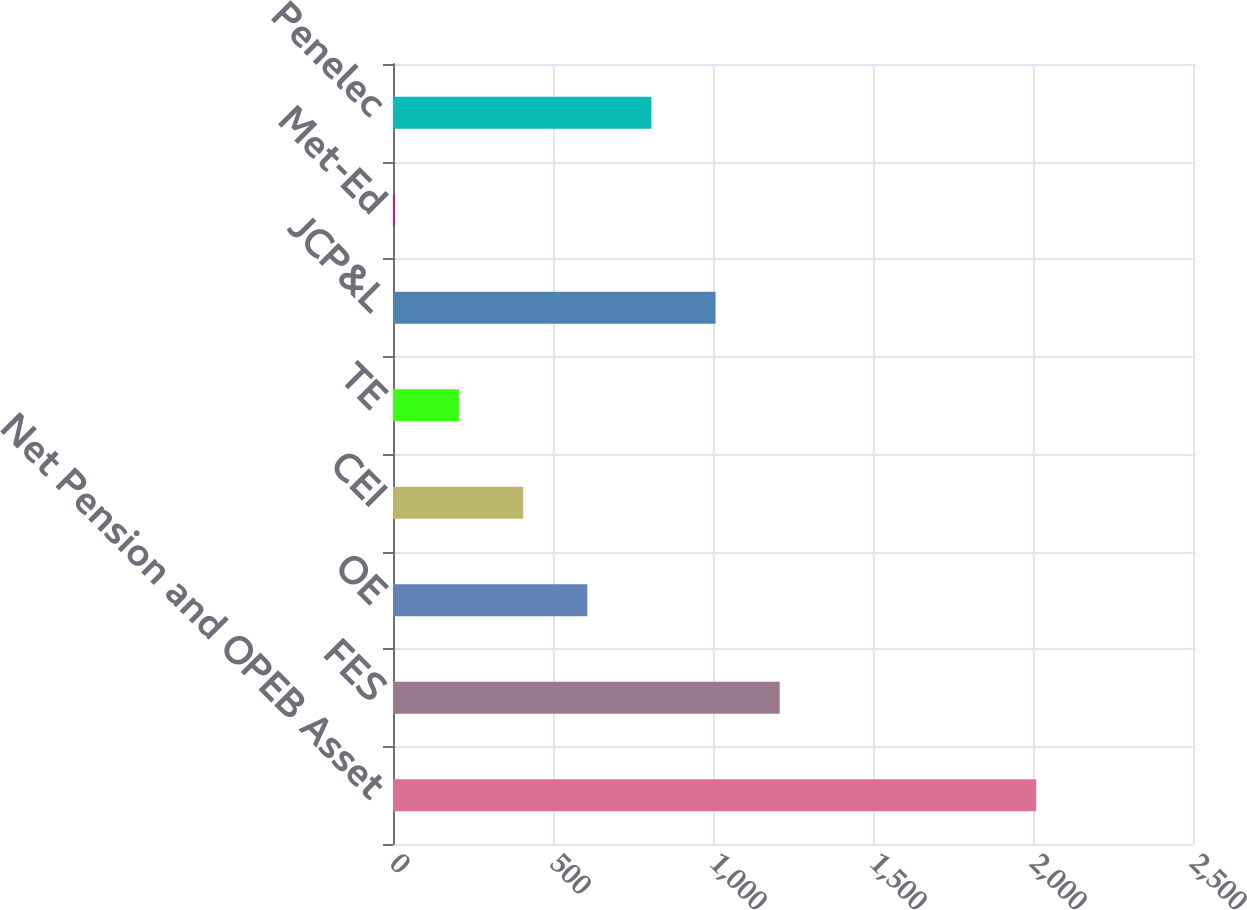<chart> <loc_0><loc_0><loc_500><loc_500><bar_chart><fcel>Net Pension and OPEB Asset<fcel>FES<fcel>OE<fcel>CEI<fcel>TE<fcel>JCP&L<fcel>Met-Ed<fcel>Penelec<nl><fcel>2010<fcel>1208.4<fcel>607.2<fcel>406.8<fcel>206.4<fcel>1008<fcel>6<fcel>807.6<nl></chart> 